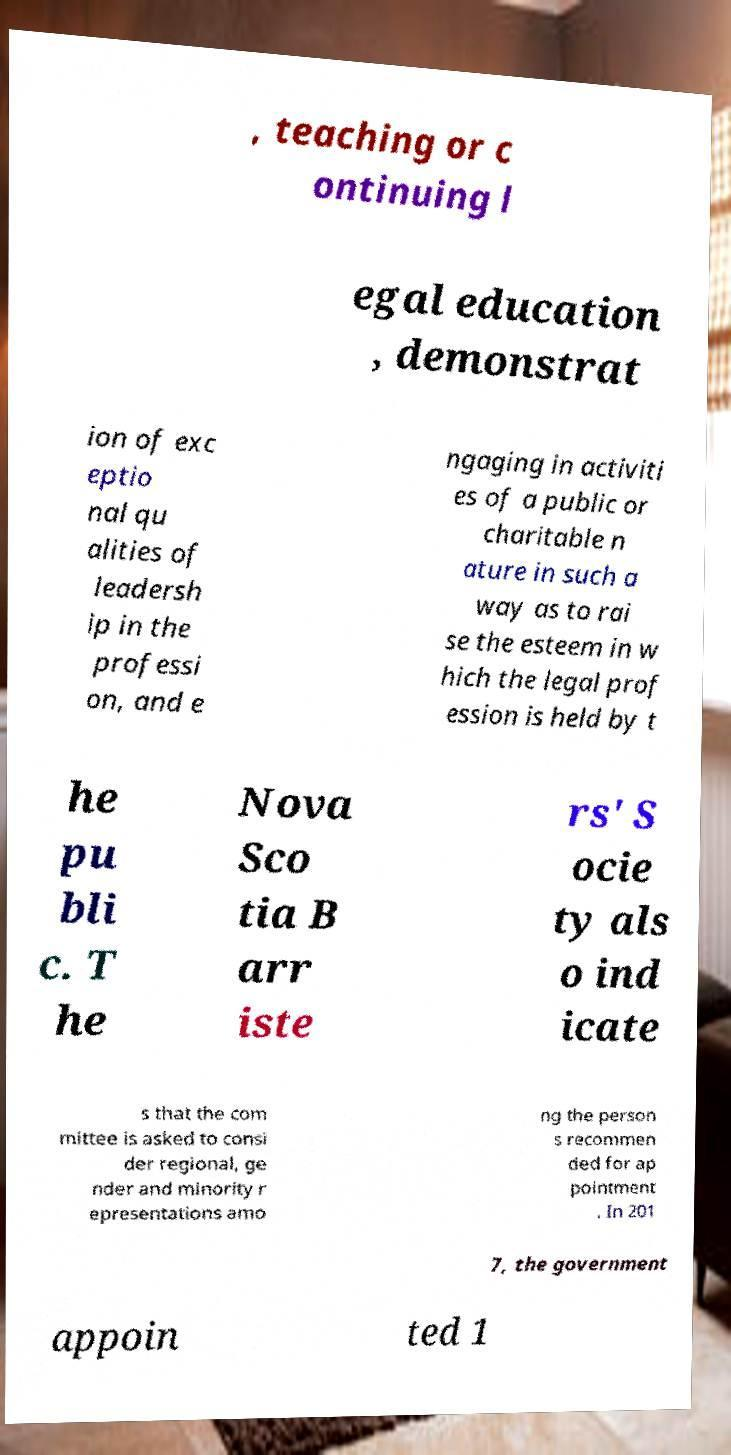Can you read and provide the text displayed in the image?This photo seems to have some interesting text. Can you extract and type it out for me? , teaching or c ontinuing l egal education , demonstrat ion of exc eptio nal qu alities of leadersh ip in the professi on, and e ngaging in activiti es of a public or charitable n ature in such a way as to rai se the esteem in w hich the legal prof ession is held by t he pu bli c. T he Nova Sco tia B arr iste rs' S ocie ty als o ind icate s that the com mittee is asked to consi der regional, ge nder and minority r epresentations amo ng the person s recommen ded for ap pointment . In 201 7, the government appoin ted 1 